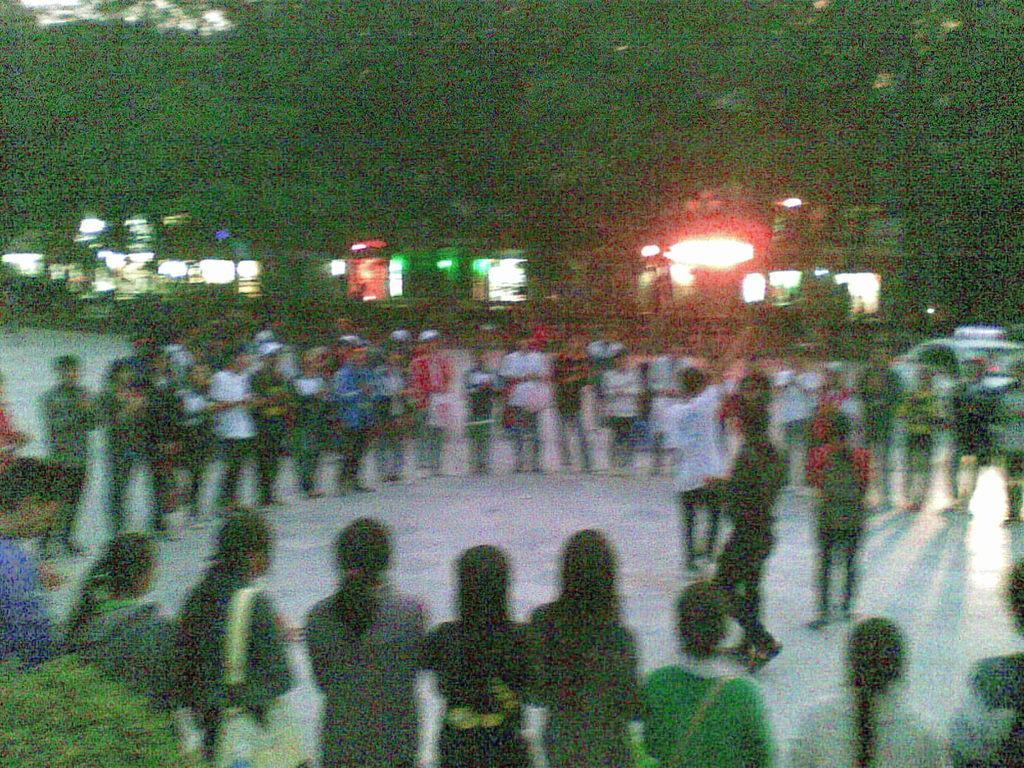Can you describe this image briefly? In this image we can see a few people on the road, there we can see few trees, plants and windows. 